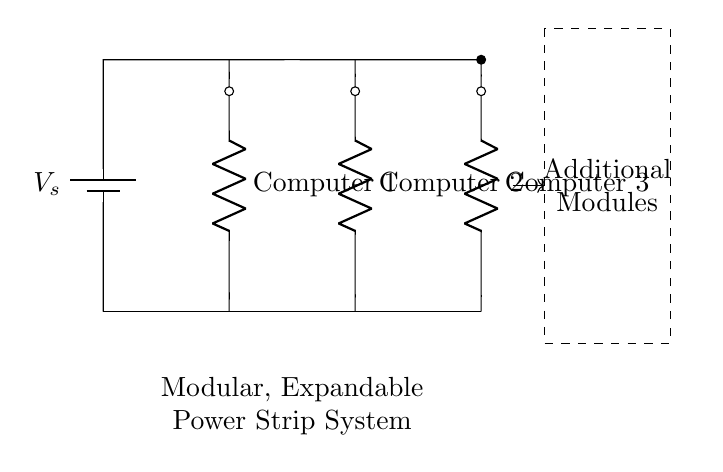What is the source voltage in this circuit? The circuit diagram labels the voltage source as V_s. This indicates that there is a variable supply voltage connected to the circuit. Without specific values given, we refer to it as V_s.
Answer: V_s How many computers are connected to the power strip system? The diagram shows three resistors labeled as Computer 1, Computer 2, and Computer 3. Each of these resistors represents a computer, indicating that three computers are connected.
Answer: Three computers Are the computers connected in series or parallel? The diagram illustrates that each computer is connected to the same horizontal voltage line, indicating that they are independent of each other in terms of voltage. This characteristic is typical of parallel connections.
Answer: Parallel What happens if one computer is turned off? In a parallel circuit, turning off one component (computer) does not affect the operation of the others. Each component receives the full voltage from the source independently, so the others will continue to function normally.
Answer: Others continue to function What is the purpose of the dashed rectangle labeled "Additional Modules"? The dashed rectangle indicates that this power strip system is designed to be expandable; it allows for adding more components or additional computers, enhancing the flexibility of the setup.
Answer: Expandability How does the current distribute among the computers in this circuit? In a parallel circuit, the total current from the source divides among the connected components based on their resistance. Each computer (resistor) will draw current according to its resistance value, so the overall current in the circuit is the sum of the currents through each computer.
Answer: Divides according to resistance 